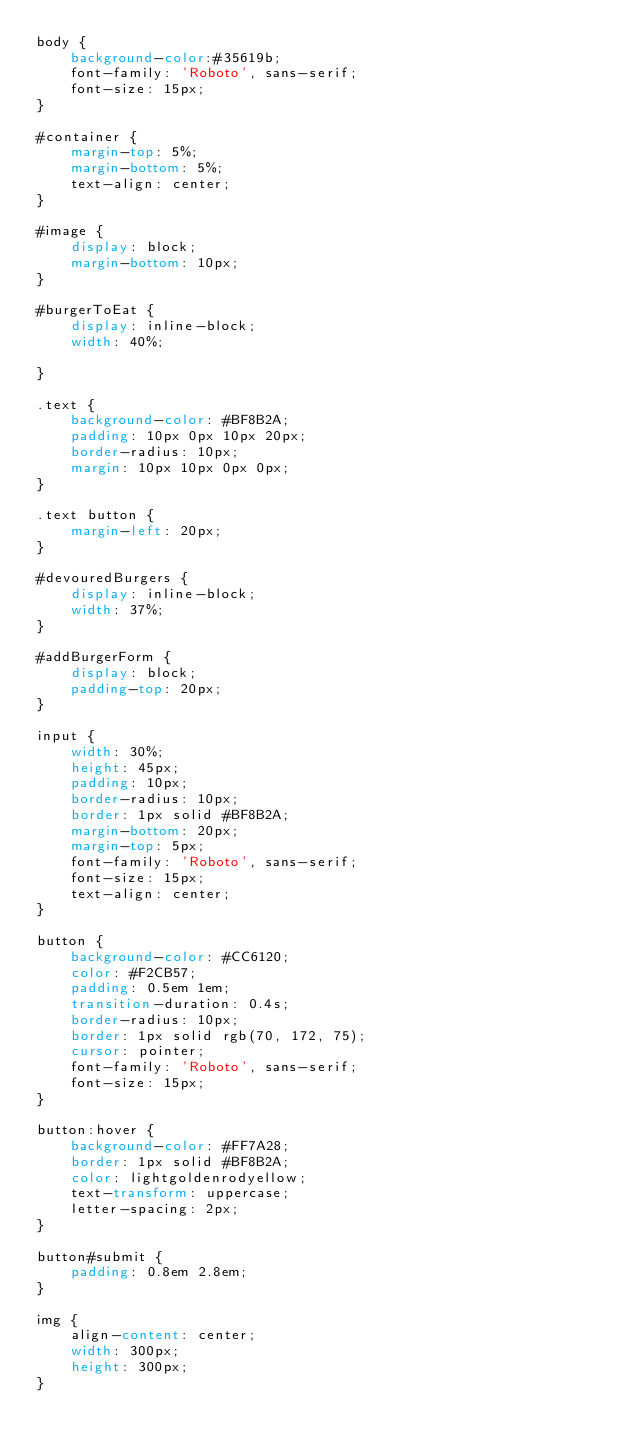<code> <loc_0><loc_0><loc_500><loc_500><_CSS_>body {
    background-color:#35619b;
    font-family: 'Roboto', sans-serif;
    font-size: 15px;
}

#container {
    margin-top: 5%;
    margin-bottom: 5%;
    text-align: center;
}

#image {
    display: block;
    margin-bottom: 10px;
}

#burgerToEat {
    display: inline-block;
    width: 40%;

}

.text {
    background-color: #BF8B2A;
    padding: 10px 0px 10px 20px;
    border-radius: 10px;
    margin: 10px 10px 0px 0px;
}

.text button {
    margin-left: 20px;
}

#devouredBurgers {
    display: inline-block;
    width: 37%;
}

#addBurgerForm {
    display: block;
    padding-top: 20px;
}

input {
    width: 30%;
    height: 45px;
    padding: 10px;
    border-radius: 10px;
    border: 1px solid #BF8B2A;
    margin-bottom: 20px;
    margin-top: 5px;
    font-family: 'Roboto', sans-serif;
    font-size: 15px;
    text-align: center;
}

button {
    background-color: #CC6120;
    color: #F2CB57;
    padding: 0.5em 1em;
    transition-duration: 0.4s;
    border-radius: 10px;
    border: 1px solid rgb(70, 172, 75);
    cursor: pointer;
    font-family: 'Roboto', sans-serif;
    font-size: 15px;
}

button:hover {
    background-color: #FF7A28;
    border: 1px solid #BF8B2A;
    color: lightgoldenrodyellow;
    text-transform: uppercase;
    letter-spacing: 2px;
}

button#submit {
    padding: 0.8em 2.8em;
}

img {
    align-content: center;
    width: 300px;
    height: 300px;
}</code> 